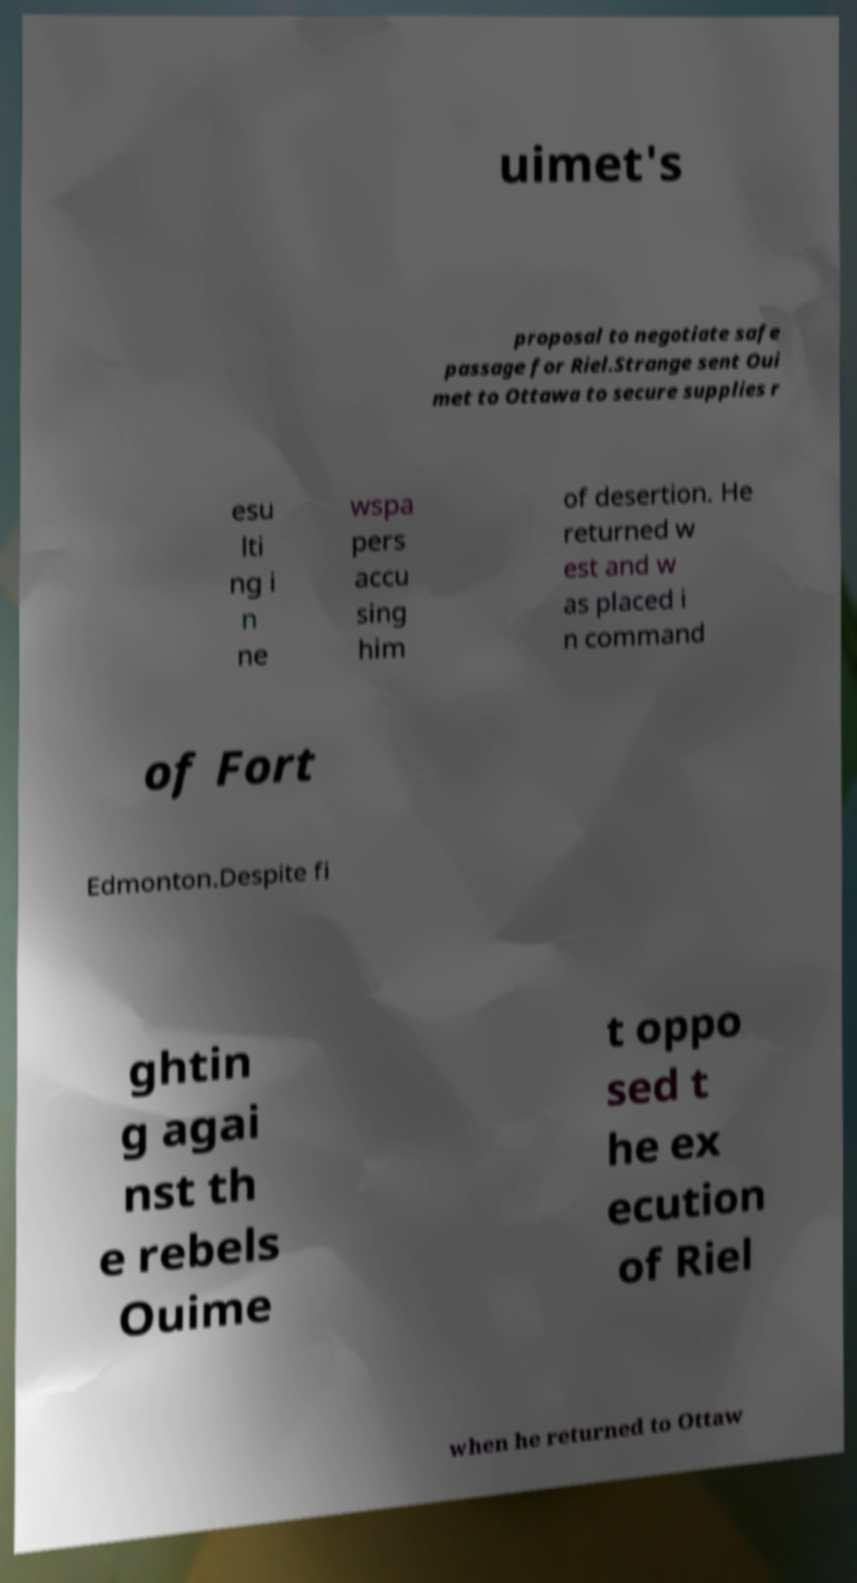I need the written content from this picture converted into text. Can you do that? uimet's proposal to negotiate safe passage for Riel.Strange sent Oui met to Ottawa to secure supplies r esu lti ng i n ne wspa pers accu sing him of desertion. He returned w est and w as placed i n command of Fort Edmonton.Despite fi ghtin g agai nst th e rebels Ouime t oppo sed t he ex ecution of Riel when he returned to Ottaw 